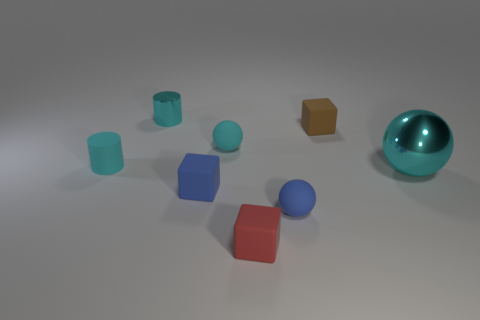Are there the same number of tiny cyan shiny cylinders that are on the right side of the brown rubber object and tiny brown matte objects to the right of the matte cylinder?
Ensure brevity in your answer.  No. How many other things are there of the same shape as the tiny cyan shiny thing?
Offer a terse response. 1. Do the object to the right of the tiny brown rubber cube and the cyan metal thing behind the large ball have the same size?
Keep it short and to the point. No. What number of cubes are tiny blue things or brown rubber things?
Offer a terse response. 2. How many matte objects are tiny blue things or red blocks?
Offer a very short reply. 3. There is a blue matte thing that is the same shape as the red thing; what size is it?
Make the answer very short. Small. Are there any other things that are the same size as the metallic sphere?
Offer a terse response. No. Does the red object have the same size as the metallic thing that is right of the tiny red block?
Provide a succinct answer. No. The metal thing that is behind the large shiny object has what shape?
Provide a short and direct response. Cylinder. What is the color of the tiny rubber cube on the left side of the rubber ball that is behind the tiny matte cylinder?
Your response must be concise. Blue. 